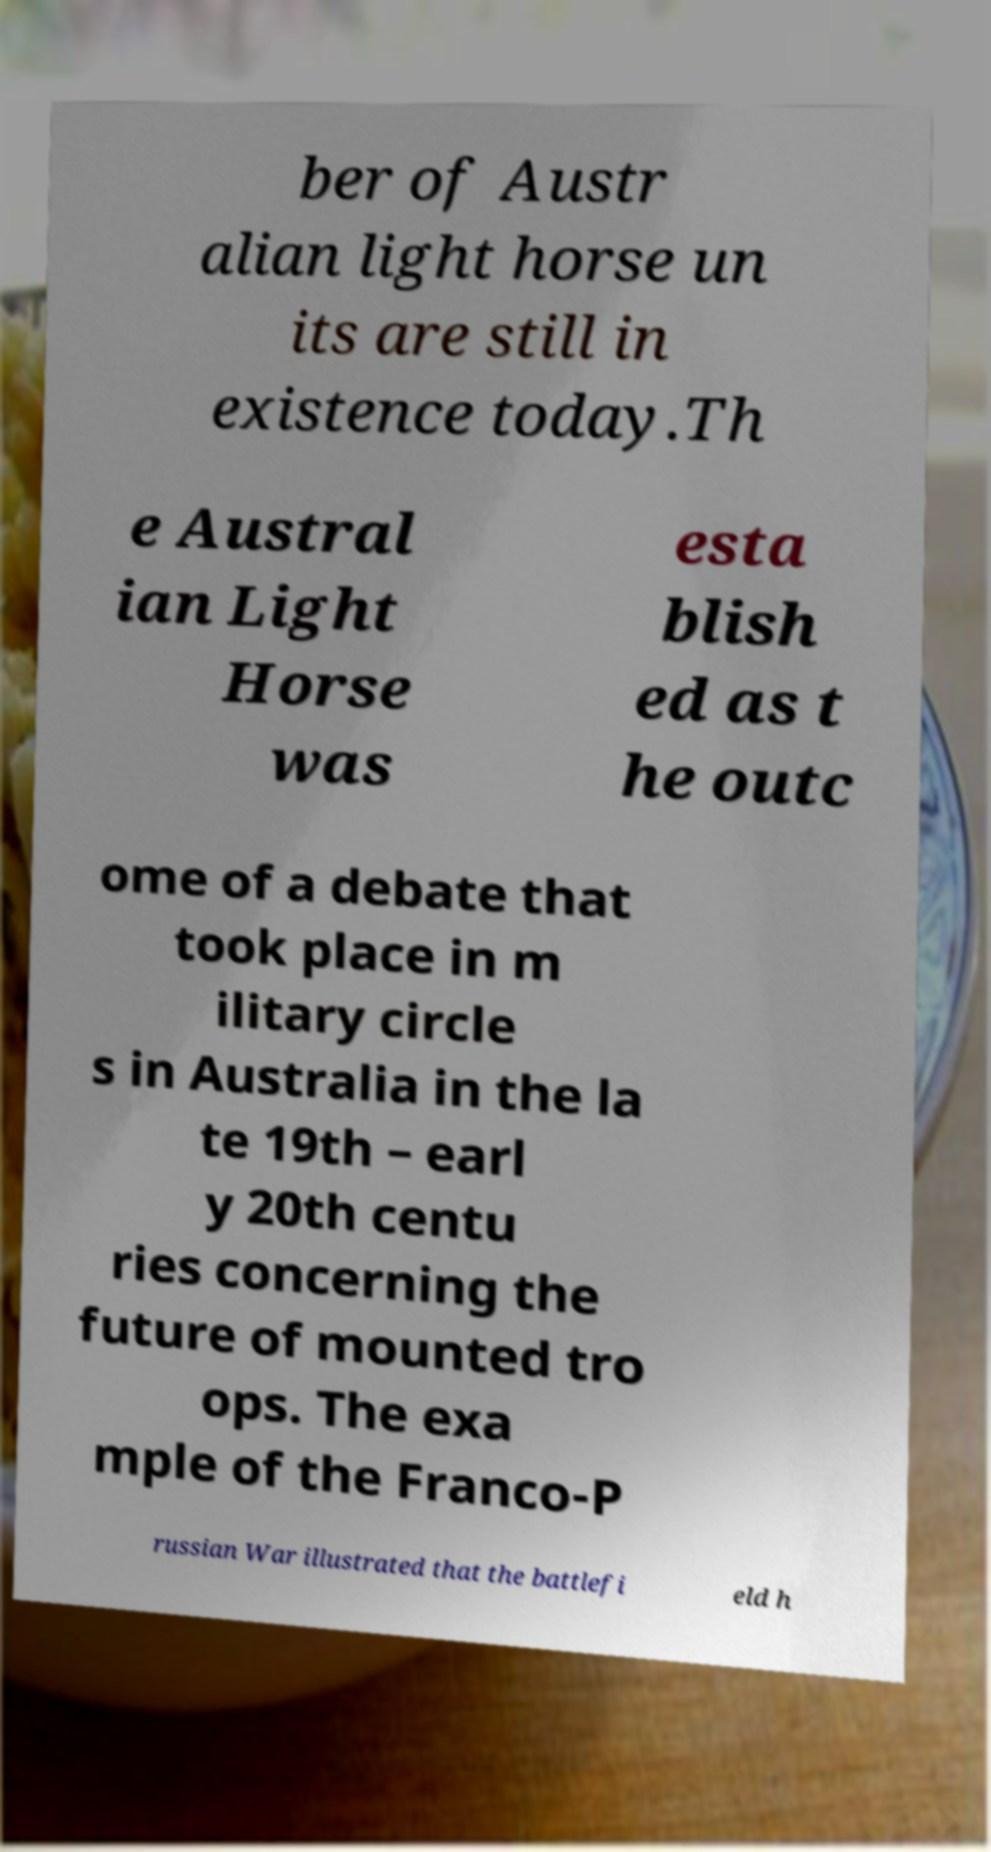Please read and relay the text visible in this image. What does it say? ber of Austr alian light horse un its are still in existence today.Th e Austral ian Light Horse was esta blish ed as t he outc ome of a debate that took place in m ilitary circle s in Australia in the la te 19th – earl y 20th centu ries concerning the future of mounted tro ops. The exa mple of the Franco-P russian War illustrated that the battlefi eld h 